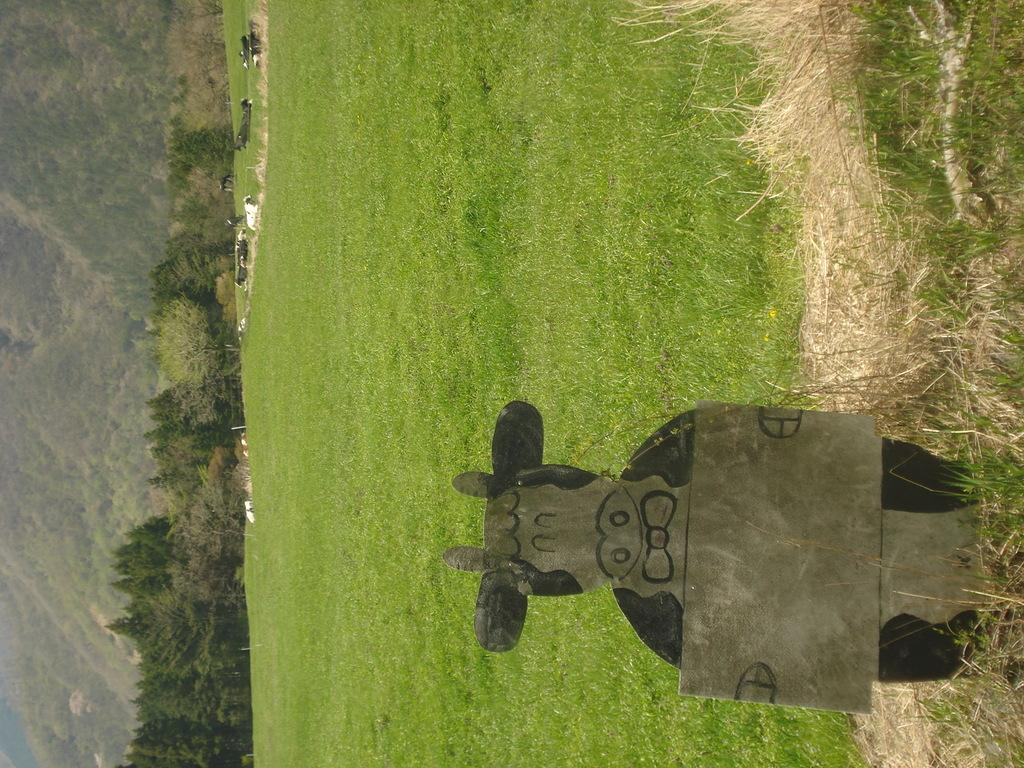What is the main subject in the foreground of the image? There is a board in the shape like a cow in the foreground of the image. What type of natural environment is visible in the background of the image? There is grass, animals, and trees in the background of the image. What story are the children telling each other while walking on the road in the image? There are no children or road present in the image. 